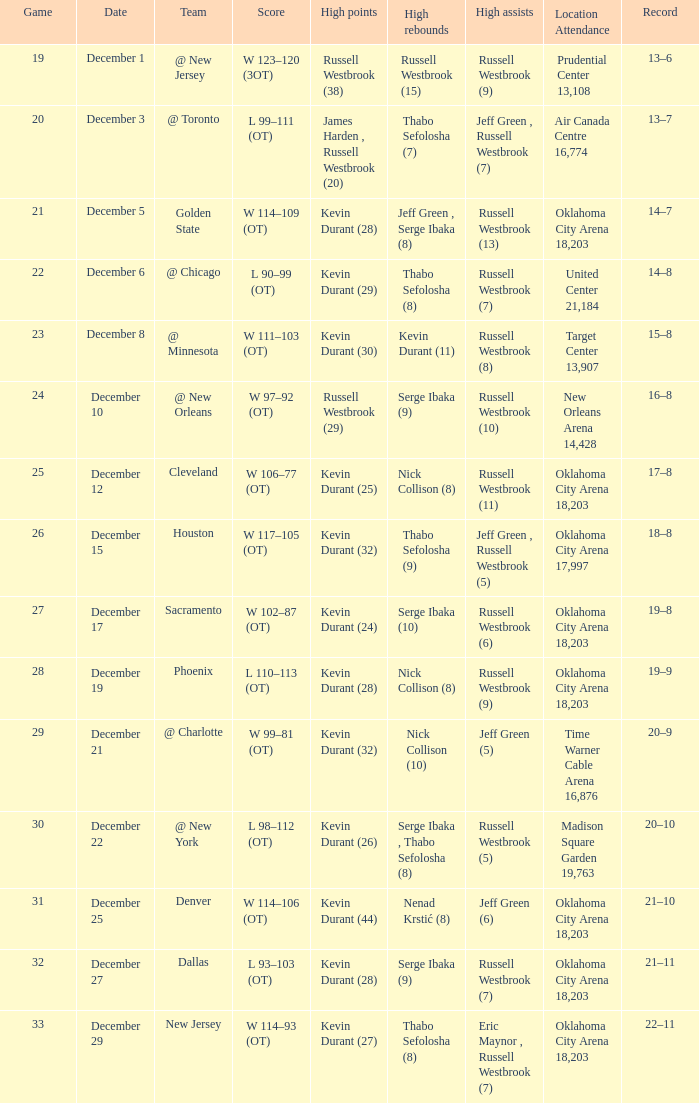What was the accomplishment on december 27? 21–11. 